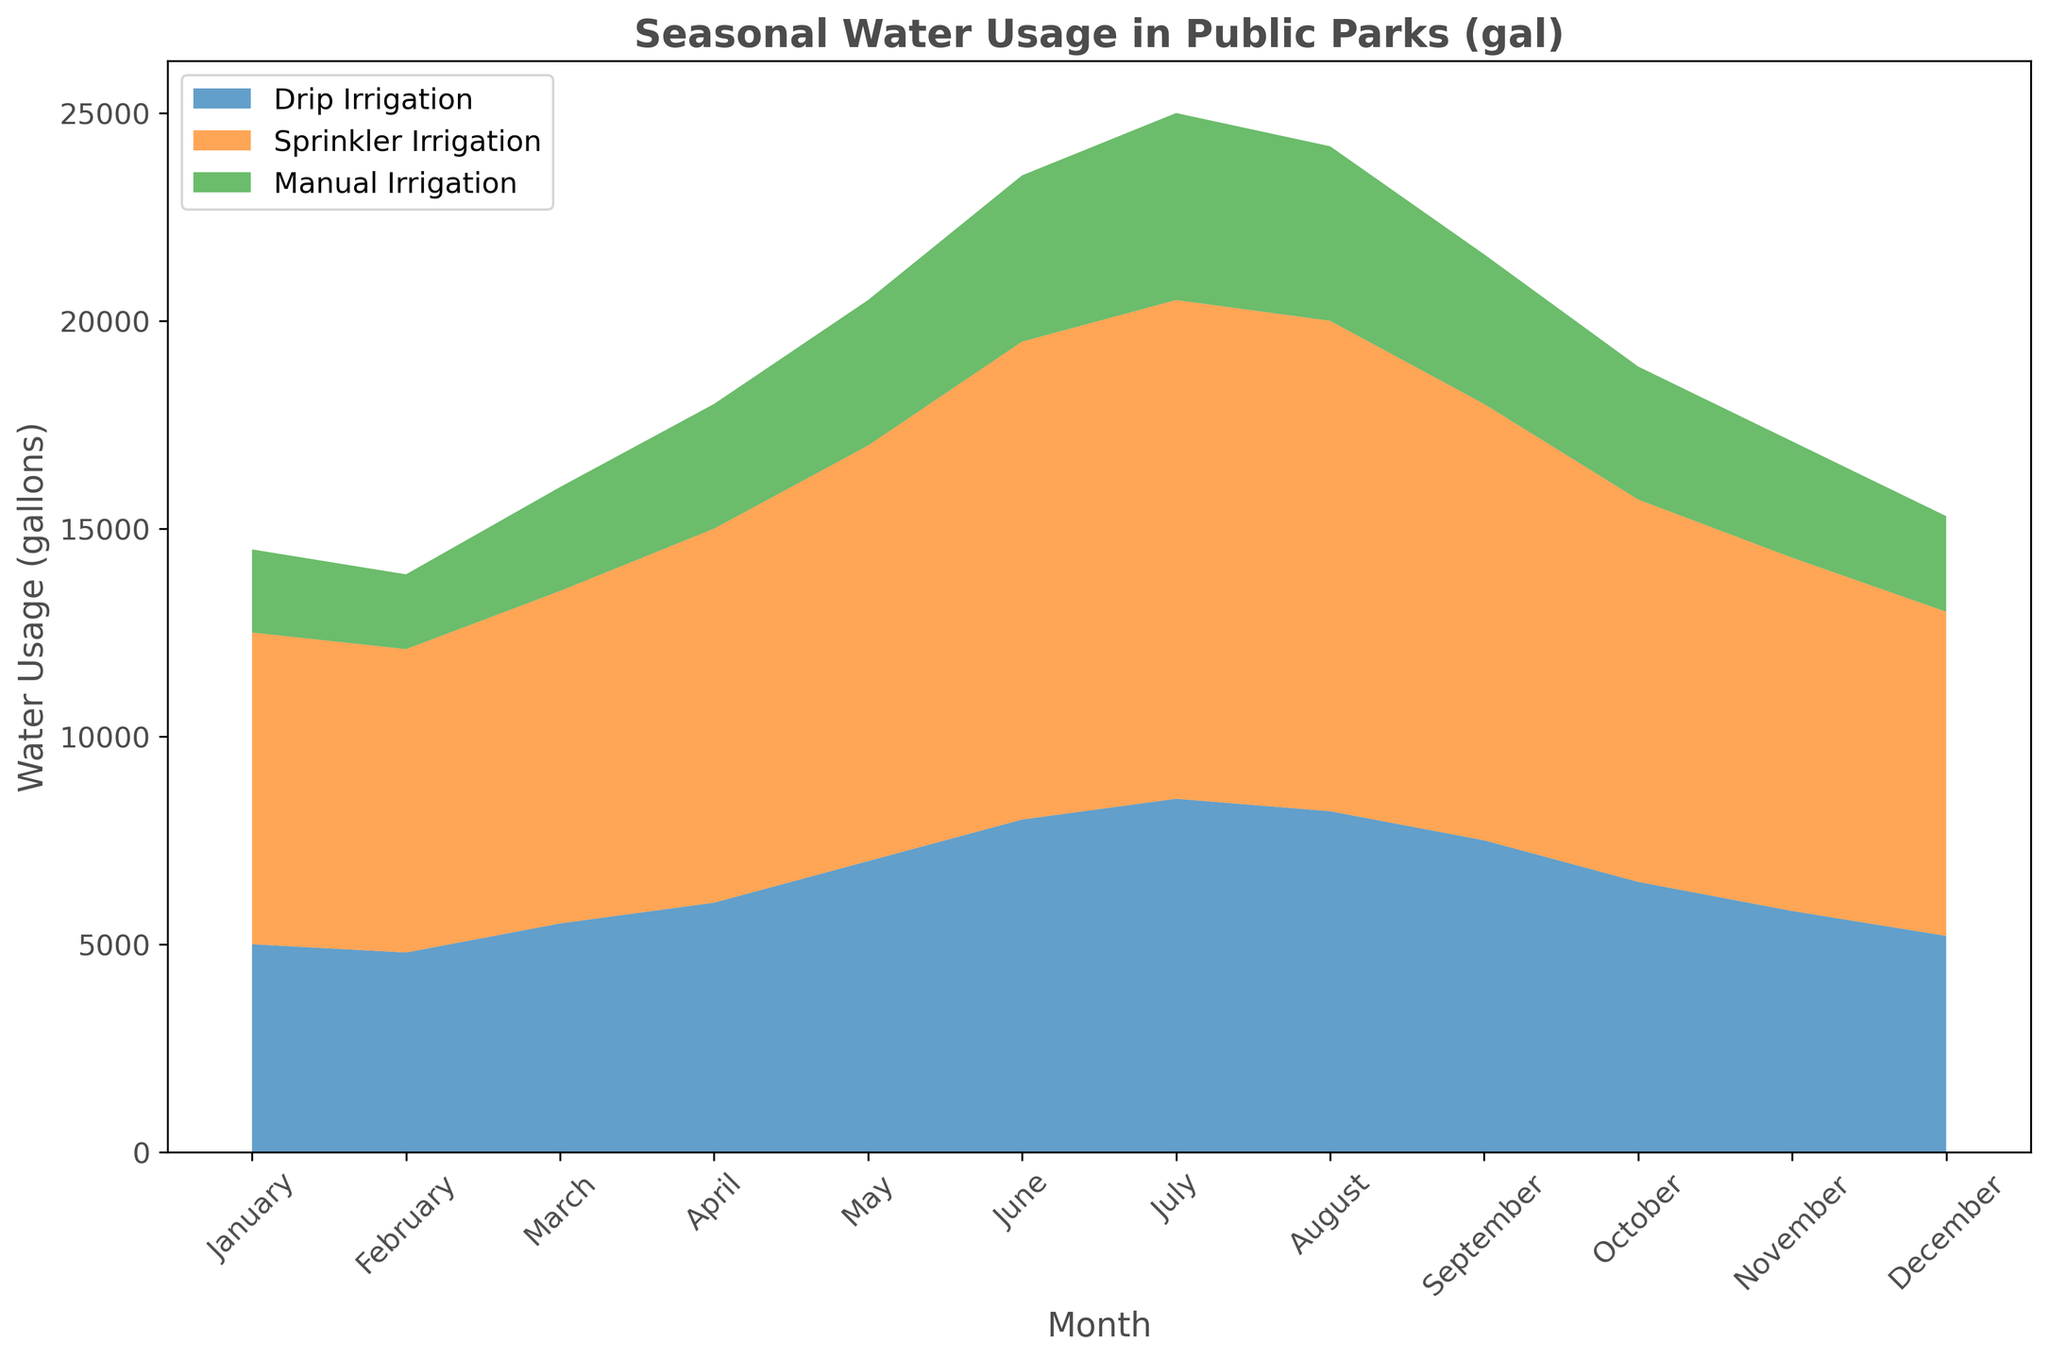What is the total water usage for all irrigation methods in July? Add the water usage for Drip Irrigation (8500 gallons), Sprinkler Irrigation (12000 gallons), and Manual Irrigation (4500 gallons). So, 8500 + 12000 + 4500 = 25000 gallons.
Answer: 25000 gallons Which month had the highest total water usage, and what was that usage? Sum the water usage of all three methods for each month and compare to find the highest. July: 25000 gallons, which is the highest among all months.
Answer: July, 25000 gallons How does the water usage of Drip Irrigation in January compare to December? Compare the values for Drip Irrigation in January (5000 gallons) and December (5200 gallons). Drip Irrigation usage in January is 200 gallons less than in December.
Answer: December uses 200 gallons more What is the average monthly water usage for Sprinkler Irrigation over the year? Sum the monthly usages (7500 + 7300 + 8000 + 9000 + 10000 + 11500 + 12000 + 11800 + 10500 + 9200 + 8500 + 7800 = 121100) and divide by 12 months: 121100 / 12 = 10091.67 gallons.
Answer: 10091.67 gallons In which month is the usage gap between Sprinkler and Manual Irrigation the largest? Calculate the difference for each month, then identify the month with the largest gap. In June, the difference is 11500 (Sprinkler) - 4000 (Manual) = 7500 gallons, the largest gap among all months.
Answer: June, 7500 gallons Which irrigation method showed the most consistent usage throughout the year, and why? Check the variability of each method's usage. Drip Irrigation ranges from 4800 to 8500 gallons, Sprinkler from 7300 to 12000 gallons, Manual from 1800 to 4500 gallons. Drip Irrigation has the smallest range, indicating most consistency.
Answer: Drip Irrigation, smallest range What are the total water usages of each irrigation method over the entire year? Sum the monthly usages for each method:
- Drip Irrigation: 5000 + 4800 + 5500 + 6000 + 7000 + 8000 + 8500 + 8200 + 7500 + 6500 + 5800 + 5200 = 78000 gallons
- Sprinkler Irrigation: 7500 + 7300 + 8000 + 9000 + 10000 + 11500 + 12000 + 11800 + 10500 + 9200 + 8500 + 7800 = 121100 gallons
- Manual Irrigation: 2000 + 1800 + 2500 + 3000 + 3500 + 4000 + 4500 + 4200 + 3600 + 3200 + 2800 + 2300 = 41400 gallons
Answer: Drip: 78000 gallons, Sprinkler: 121100 gallons, Manual: 41400 gallons 